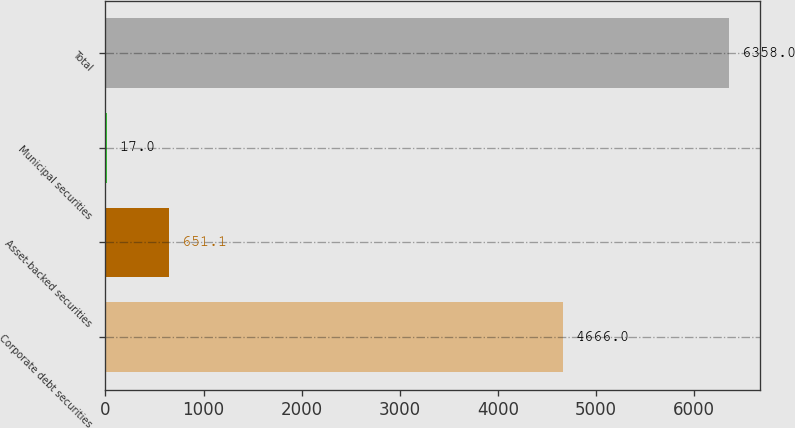Convert chart. <chart><loc_0><loc_0><loc_500><loc_500><bar_chart><fcel>Corporate debt securities<fcel>Asset-backed securities<fcel>Municipal securities<fcel>Total<nl><fcel>4666<fcel>651.1<fcel>17<fcel>6358<nl></chart> 